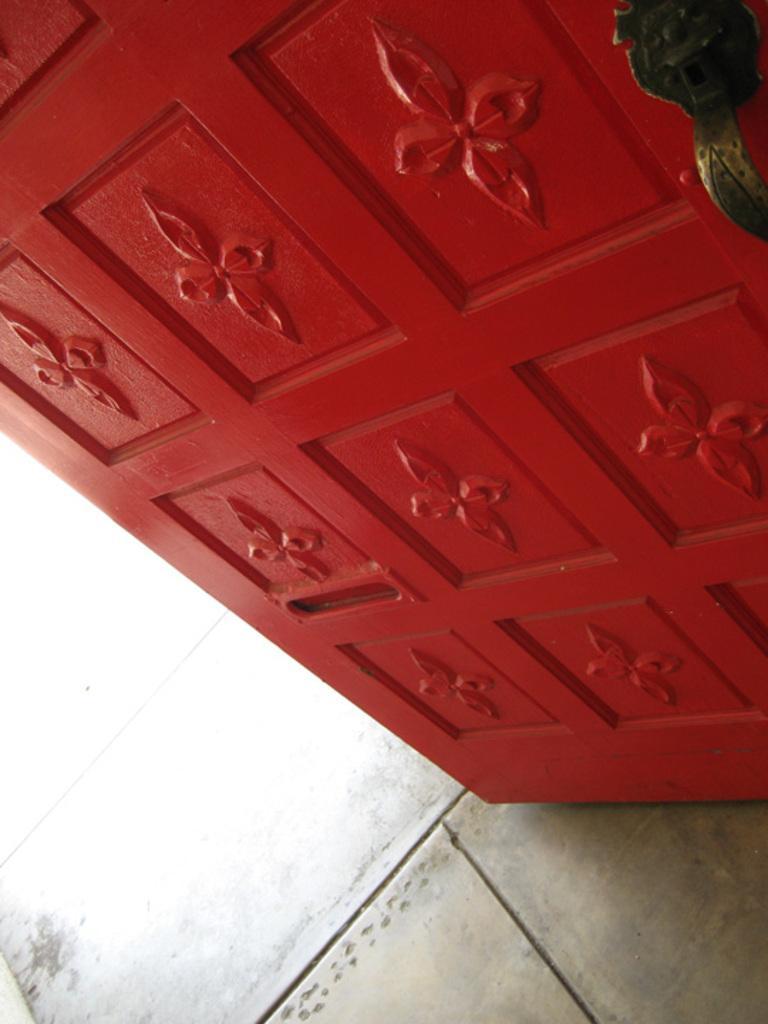Please provide a concise description of this image. In this picture I can see a door. 